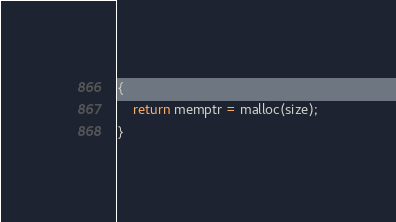<code> <loc_0><loc_0><loc_500><loc_500><_C_>{
	return memptr = malloc(size);
}
</code> 